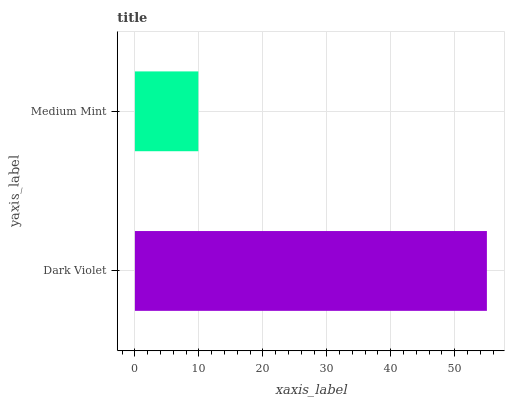Is Medium Mint the minimum?
Answer yes or no. Yes. Is Dark Violet the maximum?
Answer yes or no. Yes. Is Medium Mint the maximum?
Answer yes or no. No. Is Dark Violet greater than Medium Mint?
Answer yes or no. Yes. Is Medium Mint less than Dark Violet?
Answer yes or no. Yes. Is Medium Mint greater than Dark Violet?
Answer yes or no. No. Is Dark Violet less than Medium Mint?
Answer yes or no. No. Is Dark Violet the high median?
Answer yes or no. Yes. Is Medium Mint the low median?
Answer yes or no. Yes. Is Medium Mint the high median?
Answer yes or no. No. Is Dark Violet the low median?
Answer yes or no. No. 